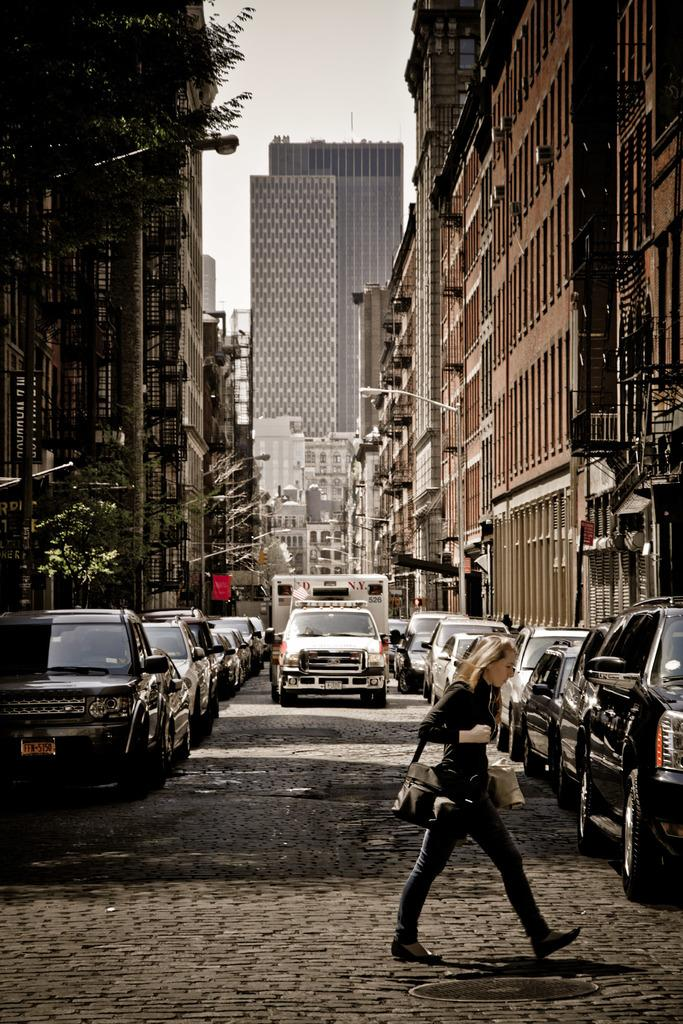<image>
Offer a succinct explanation of the picture presented. A woman is crossing a street where an Ambulance is driving that says N.Y. on it. 